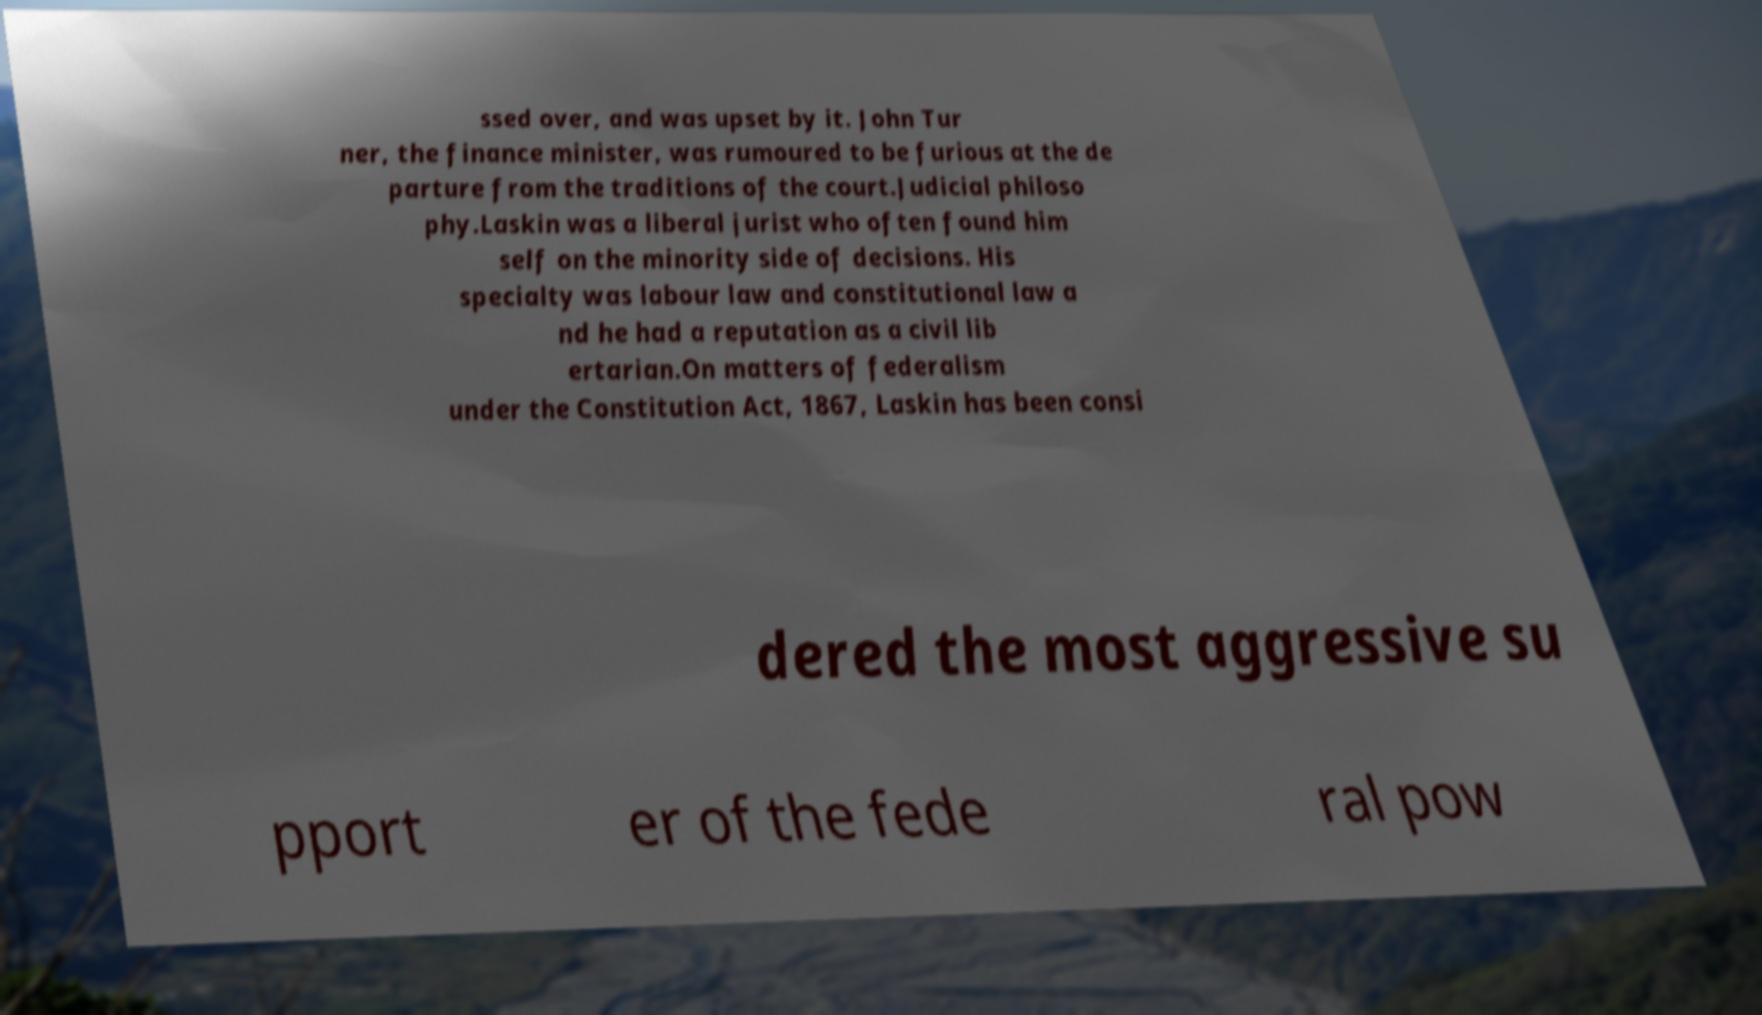Can you accurately transcribe the text from the provided image for me? ssed over, and was upset by it. John Tur ner, the finance minister, was rumoured to be furious at the de parture from the traditions of the court.Judicial philoso phy.Laskin was a liberal jurist who often found him self on the minority side of decisions. His specialty was labour law and constitutional law a nd he had a reputation as a civil lib ertarian.On matters of federalism under the Constitution Act, 1867, Laskin has been consi dered the most aggressive su pport er of the fede ral pow 